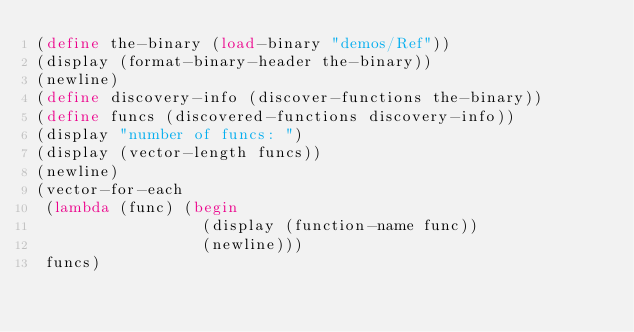<code> <loc_0><loc_0><loc_500><loc_500><_Scheme_>(define the-binary (load-binary "demos/Ref"))
(display (format-binary-header the-binary))
(newline)
(define discovery-info (discover-functions the-binary))
(define funcs (discovered-functions discovery-info))
(display "number of funcs: ")
(display (vector-length funcs))
(newline)
(vector-for-each
 (lambda (func) (begin
                  (display (function-name func))
                  (newline)))
 funcs)
</code> 